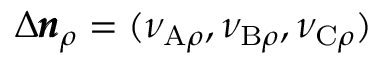<formula> <loc_0><loc_0><loc_500><loc_500>\Delta \pm b { n } _ { \rho } = ( \nu _ { A \rho } , \nu _ { B \rho } , \nu _ { C \rho } )</formula> 